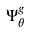<formula> <loc_0><loc_0><loc_500><loc_500>\Psi _ { \theta } ^ { g }</formula> 